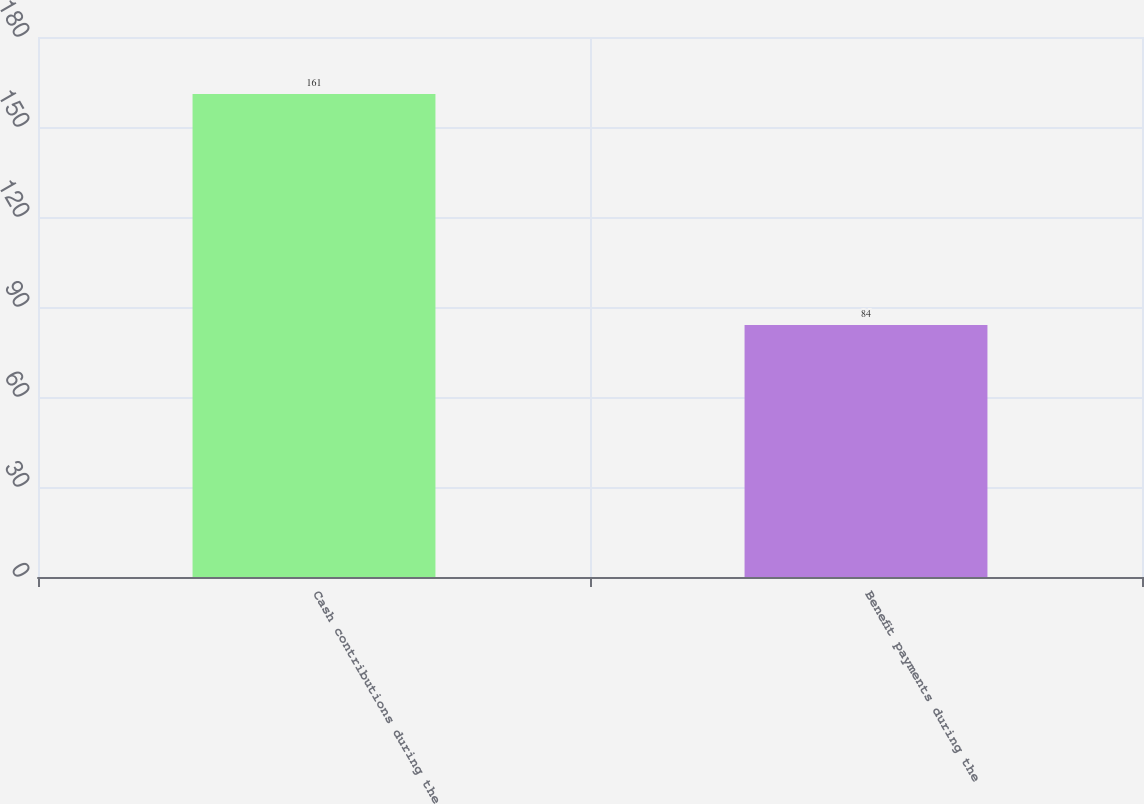Convert chart. <chart><loc_0><loc_0><loc_500><loc_500><bar_chart><fcel>Cash contributions during the<fcel>Benefit payments during the<nl><fcel>161<fcel>84<nl></chart> 